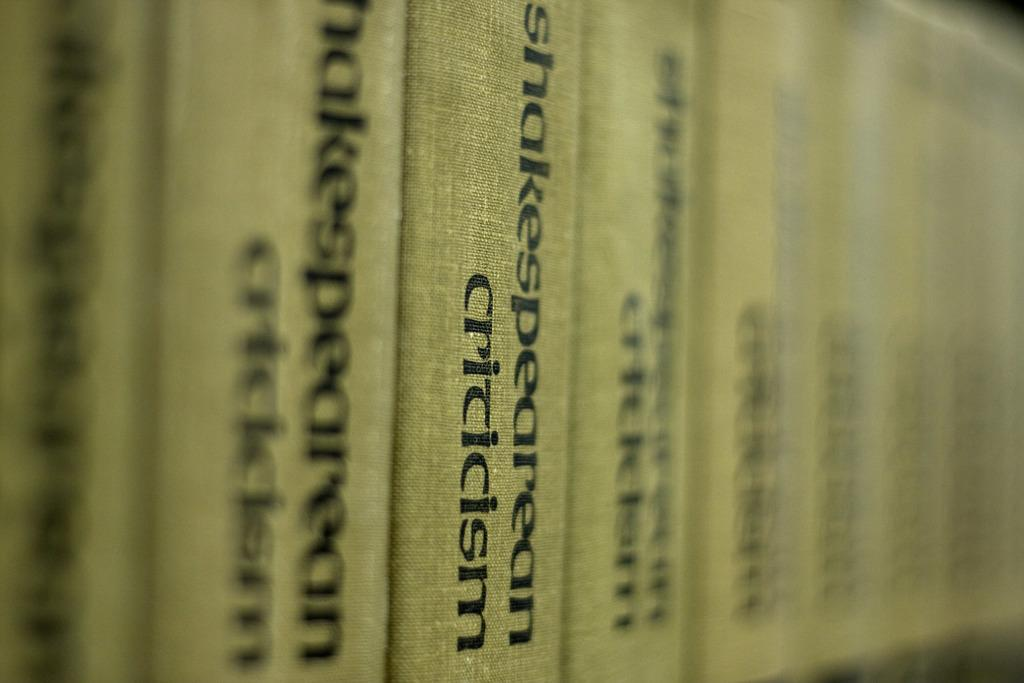Provide a one-sentence caption for the provided image. A line of books with the title Shakespearean Criticism. 